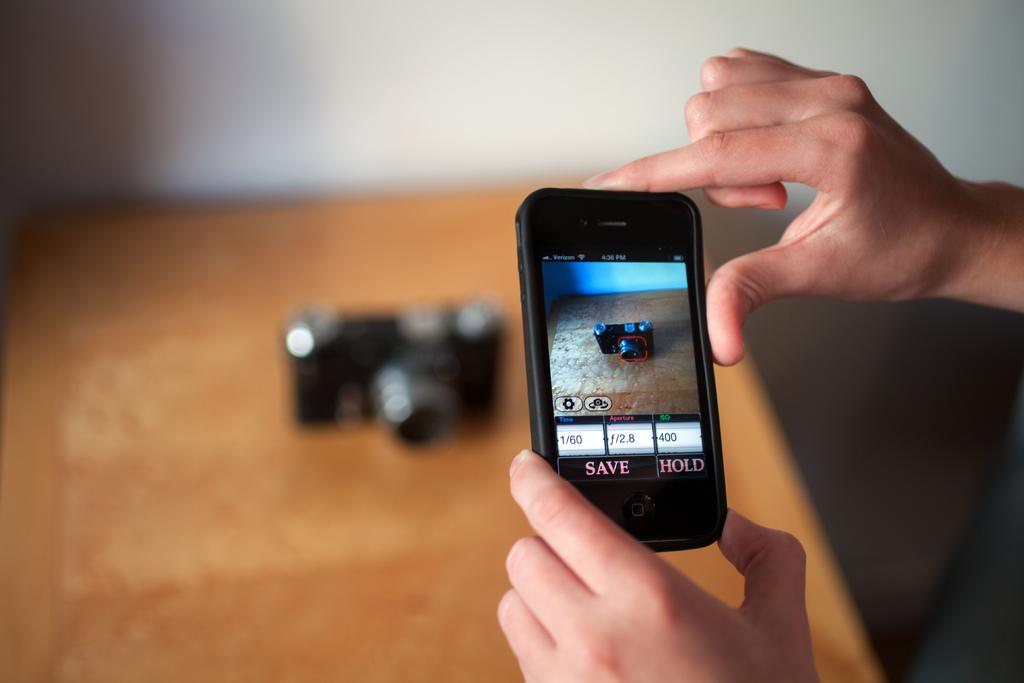What options do i have on this phone?
Offer a very short reply. Save, hold. What cell phone service provider does this person have?
Offer a terse response. Verizon. 